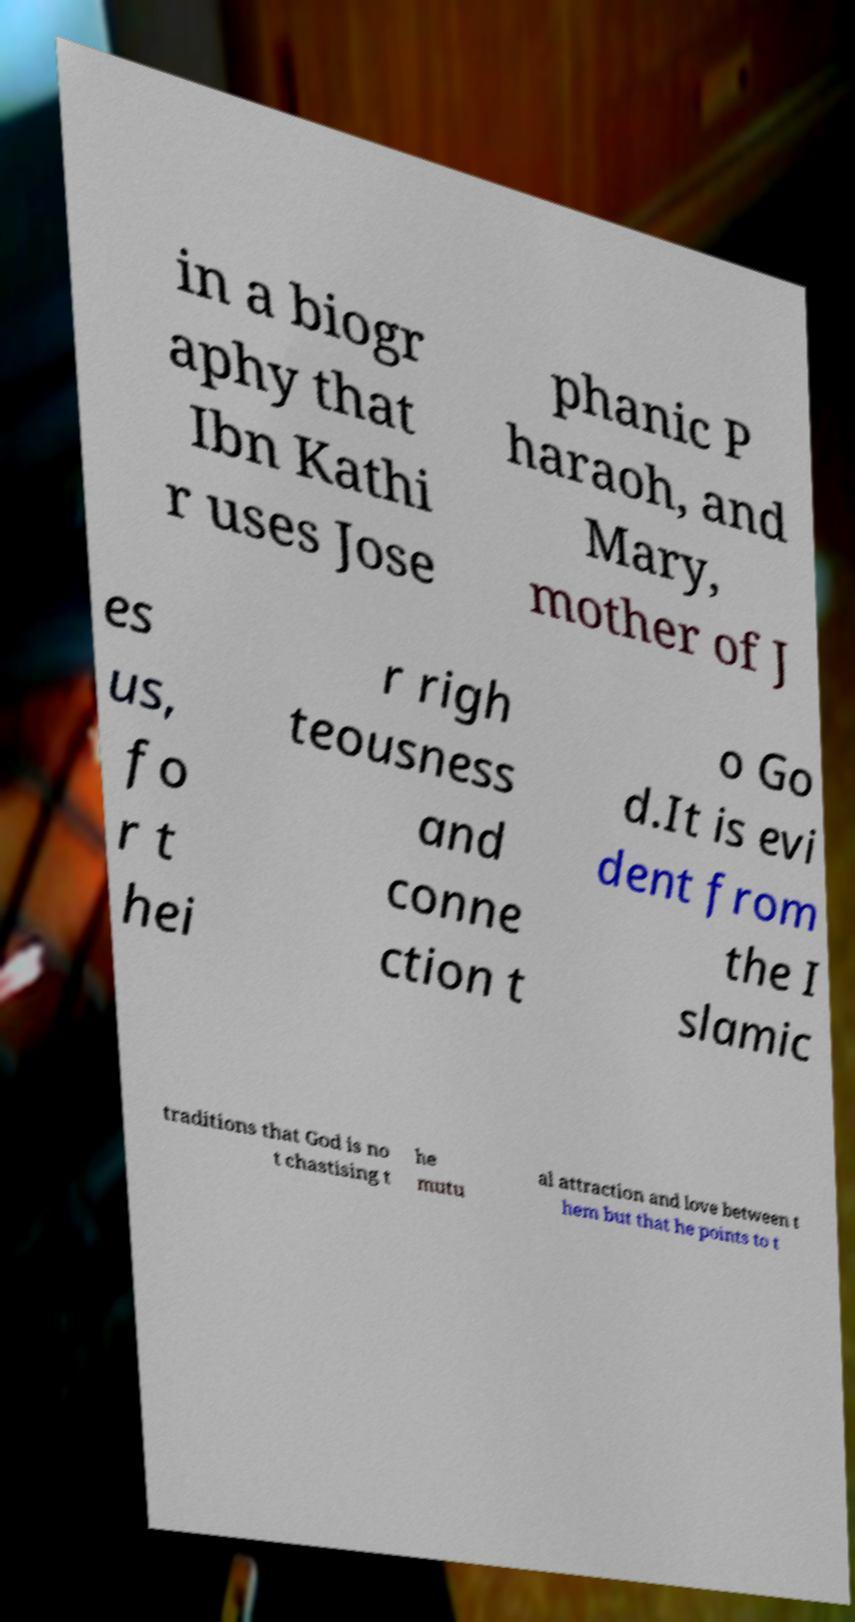Can you accurately transcribe the text from the provided image for me? in a biogr aphy that Ibn Kathi r uses Jose phanic P haraoh, and Mary, mother of J es us, fo r t hei r righ teousness and conne ction t o Go d.It is evi dent from the I slamic traditions that God is no t chastising t he mutu al attraction and love between t hem but that he points to t 